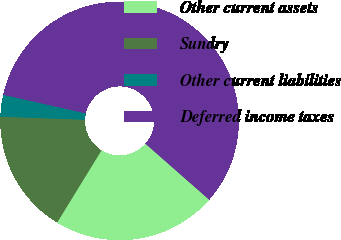<chart> <loc_0><loc_0><loc_500><loc_500><pie_chart><fcel>Other current assets<fcel>Sundry<fcel>Other current liabilities<fcel>Deferred income taxes<nl><fcel>22.29%<fcel>16.79%<fcel>2.96%<fcel>57.95%<nl></chart> 